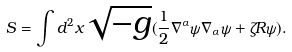<formula> <loc_0><loc_0><loc_500><loc_500>S = \int d ^ { 2 } x \sqrt { - g } ( \frac { 1 } { 2 } \nabla ^ { \alpha } \psi \nabla _ { \alpha } \psi + \zeta R \psi ) .</formula> 